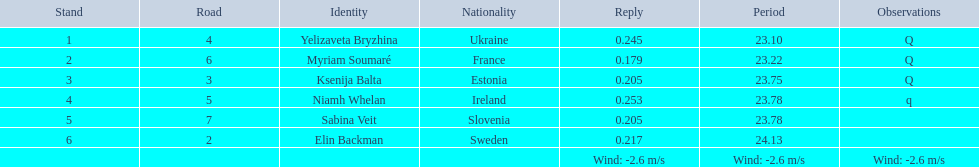What are all the names? Yelizaveta Bryzhina, Myriam Soumaré, Ksenija Balta, Niamh Whelan, Sabina Veit, Elin Backman. What were their finishing times? 23.10, 23.22, 23.75, 23.78, 23.78, 24.13. And which time was reached by ellen backman? 24.13. 